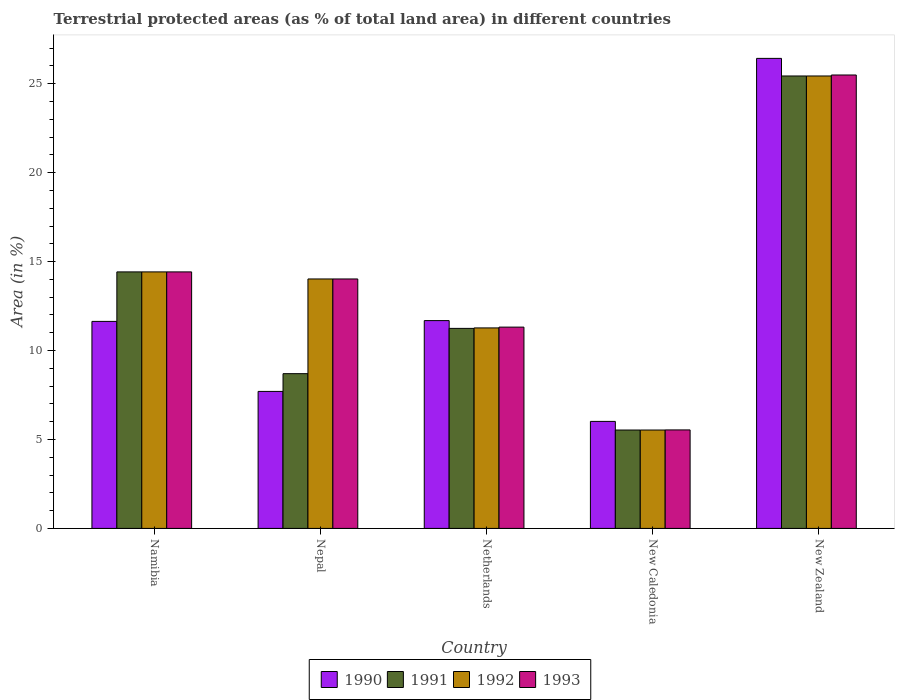Are the number of bars per tick equal to the number of legend labels?
Offer a very short reply. Yes. Are the number of bars on each tick of the X-axis equal?
Ensure brevity in your answer.  Yes. How many bars are there on the 4th tick from the left?
Provide a succinct answer. 4. What is the label of the 4th group of bars from the left?
Give a very brief answer. New Caledonia. In how many cases, is the number of bars for a given country not equal to the number of legend labels?
Keep it short and to the point. 0. What is the percentage of terrestrial protected land in 1991 in Nepal?
Make the answer very short. 8.7. Across all countries, what is the maximum percentage of terrestrial protected land in 1993?
Ensure brevity in your answer.  25.49. Across all countries, what is the minimum percentage of terrestrial protected land in 1990?
Provide a short and direct response. 6.02. In which country was the percentage of terrestrial protected land in 1990 maximum?
Ensure brevity in your answer.  New Zealand. In which country was the percentage of terrestrial protected land in 1992 minimum?
Your answer should be compact. New Caledonia. What is the total percentage of terrestrial protected land in 1990 in the graph?
Offer a terse response. 63.46. What is the difference between the percentage of terrestrial protected land in 1991 in Netherlands and that in New Caledonia?
Ensure brevity in your answer.  5.71. What is the difference between the percentage of terrestrial protected land in 1993 in Nepal and the percentage of terrestrial protected land in 1990 in Netherlands?
Offer a very short reply. 2.34. What is the average percentage of terrestrial protected land in 1991 per country?
Offer a terse response. 13.07. What is the difference between the percentage of terrestrial protected land of/in 1993 and percentage of terrestrial protected land of/in 1991 in Namibia?
Make the answer very short. 0. In how many countries, is the percentage of terrestrial protected land in 1992 greater than 2 %?
Your answer should be very brief. 5. What is the ratio of the percentage of terrestrial protected land in 1991 in Nepal to that in New Caledonia?
Your answer should be very brief. 1.57. Is the percentage of terrestrial protected land in 1993 in Namibia less than that in Netherlands?
Your answer should be compact. No. What is the difference between the highest and the second highest percentage of terrestrial protected land in 1993?
Your response must be concise. 11.07. What is the difference between the highest and the lowest percentage of terrestrial protected land in 1991?
Offer a terse response. 19.9. What does the 1st bar from the left in Nepal represents?
Provide a succinct answer. 1990. What does the 3rd bar from the right in Nepal represents?
Give a very brief answer. 1991. Is it the case that in every country, the sum of the percentage of terrestrial protected land in 1990 and percentage of terrestrial protected land in 1991 is greater than the percentage of terrestrial protected land in 1993?
Provide a short and direct response. Yes. How many countries are there in the graph?
Keep it short and to the point. 5. Does the graph contain any zero values?
Ensure brevity in your answer.  No. Does the graph contain grids?
Ensure brevity in your answer.  No. How are the legend labels stacked?
Keep it short and to the point. Horizontal. What is the title of the graph?
Offer a very short reply. Terrestrial protected areas (as % of total land area) in different countries. What is the label or title of the X-axis?
Your answer should be compact. Country. What is the label or title of the Y-axis?
Your answer should be very brief. Area (in %). What is the Area (in %) in 1990 in Namibia?
Ensure brevity in your answer.  11.64. What is the Area (in %) of 1991 in Namibia?
Your answer should be very brief. 14.42. What is the Area (in %) in 1992 in Namibia?
Make the answer very short. 14.42. What is the Area (in %) in 1993 in Namibia?
Ensure brevity in your answer.  14.42. What is the Area (in %) of 1990 in Nepal?
Provide a succinct answer. 7.7. What is the Area (in %) in 1991 in Nepal?
Your response must be concise. 8.7. What is the Area (in %) of 1992 in Nepal?
Offer a terse response. 14.02. What is the Area (in %) of 1993 in Nepal?
Provide a short and direct response. 14.02. What is the Area (in %) of 1990 in Netherlands?
Your response must be concise. 11.68. What is the Area (in %) in 1991 in Netherlands?
Provide a short and direct response. 11.25. What is the Area (in %) of 1992 in Netherlands?
Give a very brief answer. 11.27. What is the Area (in %) of 1993 in Netherlands?
Provide a short and direct response. 11.32. What is the Area (in %) in 1990 in New Caledonia?
Make the answer very short. 6.02. What is the Area (in %) in 1991 in New Caledonia?
Give a very brief answer. 5.53. What is the Area (in %) in 1992 in New Caledonia?
Ensure brevity in your answer.  5.53. What is the Area (in %) of 1993 in New Caledonia?
Make the answer very short. 5.54. What is the Area (in %) in 1990 in New Zealand?
Give a very brief answer. 26.42. What is the Area (in %) of 1991 in New Zealand?
Keep it short and to the point. 25.44. What is the Area (in %) in 1992 in New Zealand?
Your response must be concise. 25.44. What is the Area (in %) of 1993 in New Zealand?
Provide a succinct answer. 25.49. Across all countries, what is the maximum Area (in %) in 1990?
Give a very brief answer. 26.42. Across all countries, what is the maximum Area (in %) in 1991?
Give a very brief answer. 25.44. Across all countries, what is the maximum Area (in %) of 1992?
Offer a terse response. 25.44. Across all countries, what is the maximum Area (in %) in 1993?
Provide a succinct answer. 25.49. Across all countries, what is the minimum Area (in %) of 1990?
Your response must be concise. 6.02. Across all countries, what is the minimum Area (in %) of 1991?
Make the answer very short. 5.53. Across all countries, what is the minimum Area (in %) of 1992?
Your answer should be compact. 5.53. Across all countries, what is the minimum Area (in %) in 1993?
Give a very brief answer. 5.54. What is the total Area (in %) in 1990 in the graph?
Offer a very short reply. 63.46. What is the total Area (in %) in 1991 in the graph?
Provide a short and direct response. 65.33. What is the total Area (in %) in 1992 in the graph?
Your response must be concise. 70.68. What is the total Area (in %) of 1993 in the graph?
Your answer should be compact. 70.79. What is the difference between the Area (in %) in 1990 in Namibia and that in Nepal?
Give a very brief answer. 3.94. What is the difference between the Area (in %) in 1991 in Namibia and that in Nepal?
Make the answer very short. 5.72. What is the difference between the Area (in %) of 1992 in Namibia and that in Nepal?
Your response must be concise. 0.4. What is the difference between the Area (in %) in 1993 in Namibia and that in Nepal?
Give a very brief answer. 0.4. What is the difference between the Area (in %) in 1990 in Namibia and that in Netherlands?
Give a very brief answer. -0.04. What is the difference between the Area (in %) in 1991 in Namibia and that in Netherlands?
Your answer should be very brief. 3.18. What is the difference between the Area (in %) in 1992 in Namibia and that in Netherlands?
Keep it short and to the point. 3.15. What is the difference between the Area (in %) in 1993 in Namibia and that in Netherlands?
Keep it short and to the point. 3.1. What is the difference between the Area (in %) in 1990 in Namibia and that in New Caledonia?
Keep it short and to the point. 5.62. What is the difference between the Area (in %) in 1991 in Namibia and that in New Caledonia?
Your answer should be very brief. 8.89. What is the difference between the Area (in %) in 1992 in Namibia and that in New Caledonia?
Offer a terse response. 8.89. What is the difference between the Area (in %) of 1993 in Namibia and that in New Caledonia?
Ensure brevity in your answer.  8.88. What is the difference between the Area (in %) in 1990 in Namibia and that in New Zealand?
Keep it short and to the point. -14.79. What is the difference between the Area (in %) of 1991 in Namibia and that in New Zealand?
Ensure brevity in your answer.  -11.01. What is the difference between the Area (in %) in 1992 in Namibia and that in New Zealand?
Give a very brief answer. -11.02. What is the difference between the Area (in %) in 1993 in Namibia and that in New Zealand?
Give a very brief answer. -11.07. What is the difference between the Area (in %) in 1990 in Nepal and that in Netherlands?
Provide a short and direct response. -3.98. What is the difference between the Area (in %) in 1991 in Nepal and that in Netherlands?
Provide a succinct answer. -2.55. What is the difference between the Area (in %) in 1992 in Nepal and that in Netherlands?
Offer a terse response. 2.75. What is the difference between the Area (in %) of 1993 in Nepal and that in Netherlands?
Provide a short and direct response. 2.71. What is the difference between the Area (in %) of 1990 in Nepal and that in New Caledonia?
Your answer should be very brief. 1.69. What is the difference between the Area (in %) in 1991 in Nepal and that in New Caledonia?
Provide a short and direct response. 3.17. What is the difference between the Area (in %) of 1992 in Nepal and that in New Caledonia?
Your answer should be very brief. 8.49. What is the difference between the Area (in %) in 1993 in Nepal and that in New Caledonia?
Keep it short and to the point. 8.49. What is the difference between the Area (in %) in 1990 in Nepal and that in New Zealand?
Your answer should be compact. -18.72. What is the difference between the Area (in %) in 1991 in Nepal and that in New Zealand?
Provide a succinct answer. -16.74. What is the difference between the Area (in %) of 1992 in Nepal and that in New Zealand?
Provide a succinct answer. -11.41. What is the difference between the Area (in %) of 1993 in Nepal and that in New Zealand?
Ensure brevity in your answer.  -11.47. What is the difference between the Area (in %) of 1990 in Netherlands and that in New Caledonia?
Make the answer very short. 5.67. What is the difference between the Area (in %) of 1991 in Netherlands and that in New Caledonia?
Offer a terse response. 5.71. What is the difference between the Area (in %) in 1992 in Netherlands and that in New Caledonia?
Ensure brevity in your answer.  5.74. What is the difference between the Area (in %) in 1993 in Netherlands and that in New Caledonia?
Your answer should be compact. 5.78. What is the difference between the Area (in %) of 1990 in Netherlands and that in New Zealand?
Ensure brevity in your answer.  -14.74. What is the difference between the Area (in %) of 1991 in Netherlands and that in New Zealand?
Your response must be concise. -14.19. What is the difference between the Area (in %) of 1992 in Netherlands and that in New Zealand?
Your response must be concise. -14.16. What is the difference between the Area (in %) of 1993 in Netherlands and that in New Zealand?
Offer a very short reply. -14.17. What is the difference between the Area (in %) in 1990 in New Caledonia and that in New Zealand?
Make the answer very short. -20.41. What is the difference between the Area (in %) in 1991 in New Caledonia and that in New Zealand?
Keep it short and to the point. -19.9. What is the difference between the Area (in %) in 1992 in New Caledonia and that in New Zealand?
Your answer should be very brief. -19.9. What is the difference between the Area (in %) of 1993 in New Caledonia and that in New Zealand?
Your answer should be compact. -19.95. What is the difference between the Area (in %) in 1990 in Namibia and the Area (in %) in 1991 in Nepal?
Give a very brief answer. 2.94. What is the difference between the Area (in %) of 1990 in Namibia and the Area (in %) of 1992 in Nepal?
Provide a succinct answer. -2.39. What is the difference between the Area (in %) of 1990 in Namibia and the Area (in %) of 1993 in Nepal?
Give a very brief answer. -2.39. What is the difference between the Area (in %) of 1991 in Namibia and the Area (in %) of 1992 in Nepal?
Provide a short and direct response. 0.4. What is the difference between the Area (in %) in 1991 in Namibia and the Area (in %) in 1993 in Nepal?
Make the answer very short. 0.4. What is the difference between the Area (in %) in 1992 in Namibia and the Area (in %) in 1993 in Nepal?
Make the answer very short. 0.4. What is the difference between the Area (in %) in 1990 in Namibia and the Area (in %) in 1991 in Netherlands?
Your answer should be compact. 0.39. What is the difference between the Area (in %) in 1990 in Namibia and the Area (in %) in 1992 in Netherlands?
Keep it short and to the point. 0.37. What is the difference between the Area (in %) of 1990 in Namibia and the Area (in %) of 1993 in Netherlands?
Provide a succinct answer. 0.32. What is the difference between the Area (in %) in 1991 in Namibia and the Area (in %) in 1992 in Netherlands?
Your response must be concise. 3.15. What is the difference between the Area (in %) in 1991 in Namibia and the Area (in %) in 1993 in Netherlands?
Provide a short and direct response. 3.1. What is the difference between the Area (in %) in 1992 in Namibia and the Area (in %) in 1993 in Netherlands?
Give a very brief answer. 3.1. What is the difference between the Area (in %) in 1990 in Namibia and the Area (in %) in 1991 in New Caledonia?
Keep it short and to the point. 6.11. What is the difference between the Area (in %) of 1990 in Namibia and the Area (in %) of 1992 in New Caledonia?
Offer a terse response. 6.11. What is the difference between the Area (in %) in 1990 in Namibia and the Area (in %) in 1993 in New Caledonia?
Provide a short and direct response. 6.1. What is the difference between the Area (in %) of 1991 in Namibia and the Area (in %) of 1992 in New Caledonia?
Provide a short and direct response. 8.89. What is the difference between the Area (in %) in 1991 in Namibia and the Area (in %) in 1993 in New Caledonia?
Give a very brief answer. 8.88. What is the difference between the Area (in %) in 1992 in Namibia and the Area (in %) in 1993 in New Caledonia?
Offer a terse response. 8.88. What is the difference between the Area (in %) of 1990 in Namibia and the Area (in %) of 1991 in New Zealand?
Offer a very short reply. -13.8. What is the difference between the Area (in %) in 1990 in Namibia and the Area (in %) in 1992 in New Zealand?
Keep it short and to the point. -13.8. What is the difference between the Area (in %) of 1990 in Namibia and the Area (in %) of 1993 in New Zealand?
Keep it short and to the point. -13.85. What is the difference between the Area (in %) in 1991 in Namibia and the Area (in %) in 1992 in New Zealand?
Provide a short and direct response. -11.02. What is the difference between the Area (in %) of 1991 in Namibia and the Area (in %) of 1993 in New Zealand?
Give a very brief answer. -11.07. What is the difference between the Area (in %) of 1992 in Namibia and the Area (in %) of 1993 in New Zealand?
Offer a terse response. -11.07. What is the difference between the Area (in %) of 1990 in Nepal and the Area (in %) of 1991 in Netherlands?
Offer a terse response. -3.54. What is the difference between the Area (in %) in 1990 in Nepal and the Area (in %) in 1992 in Netherlands?
Your answer should be very brief. -3.57. What is the difference between the Area (in %) of 1990 in Nepal and the Area (in %) of 1993 in Netherlands?
Provide a short and direct response. -3.61. What is the difference between the Area (in %) of 1991 in Nepal and the Area (in %) of 1992 in Netherlands?
Offer a terse response. -2.57. What is the difference between the Area (in %) of 1991 in Nepal and the Area (in %) of 1993 in Netherlands?
Keep it short and to the point. -2.62. What is the difference between the Area (in %) of 1992 in Nepal and the Area (in %) of 1993 in Netherlands?
Keep it short and to the point. 2.71. What is the difference between the Area (in %) of 1990 in Nepal and the Area (in %) of 1991 in New Caledonia?
Provide a short and direct response. 2.17. What is the difference between the Area (in %) of 1990 in Nepal and the Area (in %) of 1992 in New Caledonia?
Provide a succinct answer. 2.17. What is the difference between the Area (in %) of 1990 in Nepal and the Area (in %) of 1993 in New Caledonia?
Give a very brief answer. 2.16. What is the difference between the Area (in %) in 1991 in Nepal and the Area (in %) in 1992 in New Caledonia?
Give a very brief answer. 3.17. What is the difference between the Area (in %) in 1991 in Nepal and the Area (in %) in 1993 in New Caledonia?
Ensure brevity in your answer.  3.16. What is the difference between the Area (in %) in 1992 in Nepal and the Area (in %) in 1993 in New Caledonia?
Make the answer very short. 8.49. What is the difference between the Area (in %) in 1990 in Nepal and the Area (in %) in 1991 in New Zealand?
Your response must be concise. -17.73. What is the difference between the Area (in %) of 1990 in Nepal and the Area (in %) of 1992 in New Zealand?
Offer a very short reply. -17.73. What is the difference between the Area (in %) in 1990 in Nepal and the Area (in %) in 1993 in New Zealand?
Keep it short and to the point. -17.79. What is the difference between the Area (in %) of 1991 in Nepal and the Area (in %) of 1992 in New Zealand?
Your answer should be very brief. -16.74. What is the difference between the Area (in %) of 1991 in Nepal and the Area (in %) of 1993 in New Zealand?
Make the answer very short. -16.79. What is the difference between the Area (in %) of 1992 in Nepal and the Area (in %) of 1993 in New Zealand?
Your answer should be compact. -11.47. What is the difference between the Area (in %) of 1990 in Netherlands and the Area (in %) of 1991 in New Caledonia?
Keep it short and to the point. 6.15. What is the difference between the Area (in %) in 1990 in Netherlands and the Area (in %) in 1992 in New Caledonia?
Provide a succinct answer. 6.15. What is the difference between the Area (in %) in 1990 in Netherlands and the Area (in %) in 1993 in New Caledonia?
Your answer should be very brief. 6.15. What is the difference between the Area (in %) in 1991 in Netherlands and the Area (in %) in 1992 in New Caledonia?
Ensure brevity in your answer.  5.71. What is the difference between the Area (in %) in 1991 in Netherlands and the Area (in %) in 1993 in New Caledonia?
Make the answer very short. 5.71. What is the difference between the Area (in %) in 1992 in Netherlands and the Area (in %) in 1993 in New Caledonia?
Give a very brief answer. 5.73. What is the difference between the Area (in %) of 1990 in Netherlands and the Area (in %) of 1991 in New Zealand?
Your response must be concise. -13.75. What is the difference between the Area (in %) of 1990 in Netherlands and the Area (in %) of 1992 in New Zealand?
Your answer should be compact. -13.75. What is the difference between the Area (in %) in 1990 in Netherlands and the Area (in %) in 1993 in New Zealand?
Your response must be concise. -13.81. What is the difference between the Area (in %) of 1991 in Netherlands and the Area (in %) of 1992 in New Zealand?
Offer a terse response. -14.19. What is the difference between the Area (in %) of 1991 in Netherlands and the Area (in %) of 1993 in New Zealand?
Provide a short and direct response. -14.25. What is the difference between the Area (in %) of 1992 in Netherlands and the Area (in %) of 1993 in New Zealand?
Offer a very short reply. -14.22. What is the difference between the Area (in %) of 1990 in New Caledonia and the Area (in %) of 1991 in New Zealand?
Provide a short and direct response. -19.42. What is the difference between the Area (in %) of 1990 in New Caledonia and the Area (in %) of 1992 in New Zealand?
Make the answer very short. -19.42. What is the difference between the Area (in %) in 1990 in New Caledonia and the Area (in %) in 1993 in New Zealand?
Keep it short and to the point. -19.47. What is the difference between the Area (in %) in 1991 in New Caledonia and the Area (in %) in 1992 in New Zealand?
Provide a succinct answer. -19.9. What is the difference between the Area (in %) in 1991 in New Caledonia and the Area (in %) in 1993 in New Zealand?
Provide a succinct answer. -19.96. What is the difference between the Area (in %) in 1992 in New Caledonia and the Area (in %) in 1993 in New Zealand?
Make the answer very short. -19.96. What is the average Area (in %) in 1990 per country?
Give a very brief answer. 12.69. What is the average Area (in %) of 1991 per country?
Provide a short and direct response. 13.07. What is the average Area (in %) of 1992 per country?
Your response must be concise. 14.14. What is the average Area (in %) of 1993 per country?
Your response must be concise. 14.16. What is the difference between the Area (in %) of 1990 and Area (in %) of 1991 in Namibia?
Keep it short and to the point. -2.78. What is the difference between the Area (in %) in 1990 and Area (in %) in 1992 in Namibia?
Make the answer very short. -2.78. What is the difference between the Area (in %) of 1990 and Area (in %) of 1993 in Namibia?
Your answer should be very brief. -2.78. What is the difference between the Area (in %) in 1991 and Area (in %) in 1992 in Namibia?
Ensure brevity in your answer.  0. What is the difference between the Area (in %) in 1991 and Area (in %) in 1993 in Namibia?
Ensure brevity in your answer.  0. What is the difference between the Area (in %) in 1992 and Area (in %) in 1993 in Namibia?
Ensure brevity in your answer.  0. What is the difference between the Area (in %) in 1990 and Area (in %) in 1991 in Nepal?
Provide a short and direct response. -1. What is the difference between the Area (in %) in 1990 and Area (in %) in 1992 in Nepal?
Your answer should be very brief. -6.32. What is the difference between the Area (in %) of 1990 and Area (in %) of 1993 in Nepal?
Provide a short and direct response. -6.32. What is the difference between the Area (in %) of 1991 and Area (in %) of 1992 in Nepal?
Your answer should be compact. -5.32. What is the difference between the Area (in %) in 1991 and Area (in %) in 1993 in Nepal?
Provide a short and direct response. -5.32. What is the difference between the Area (in %) of 1992 and Area (in %) of 1993 in Nepal?
Offer a very short reply. 0. What is the difference between the Area (in %) in 1990 and Area (in %) in 1991 in Netherlands?
Offer a terse response. 0.44. What is the difference between the Area (in %) of 1990 and Area (in %) of 1992 in Netherlands?
Your answer should be very brief. 0.41. What is the difference between the Area (in %) of 1990 and Area (in %) of 1993 in Netherlands?
Provide a short and direct response. 0.37. What is the difference between the Area (in %) in 1991 and Area (in %) in 1992 in Netherlands?
Offer a terse response. -0.03. What is the difference between the Area (in %) of 1991 and Area (in %) of 1993 in Netherlands?
Your response must be concise. -0.07. What is the difference between the Area (in %) of 1992 and Area (in %) of 1993 in Netherlands?
Offer a very short reply. -0.05. What is the difference between the Area (in %) in 1990 and Area (in %) in 1991 in New Caledonia?
Your answer should be very brief. 0.48. What is the difference between the Area (in %) of 1990 and Area (in %) of 1992 in New Caledonia?
Your answer should be compact. 0.48. What is the difference between the Area (in %) of 1990 and Area (in %) of 1993 in New Caledonia?
Give a very brief answer. 0.48. What is the difference between the Area (in %) of 1991 and Area (in %) of 1993 in New Caledonia?
Ensure brevity in your answer.  -0.01. What is the difference between the Area (in %) in 1992 and Area (in %) in 1993 in New Caledonia?
Provide a short and direct response. -0.01. What is the difference between the Area (in %) in 1990 and Area (in %) in 1991 in New Zealand?
Make the answer very short. 0.99. What is the difference between the Area (in %) in 1990 and Area (in %) in 1992 in New Zealand?
Offer a very short reply. 0.99. What is the difference between the Area (in %) of 1990 and Area (in %) of 1993 in New Zealand?
Your response must be concise. 0.93. What is the difference between the Area (in %) in 1991 and Area (in %) in 1992 in New Zealand?
Provide a short and direct response. -0. What is the difference between the Area (in %) in 1991 and Area (in %) in 1993 in New Zealand?
Ensure brevity in your answer.  -0.06. What is the difference between the Area (in %) in 1992 and Area (in %) in 1993 in New Zealand?
Your answer should be very brief. -0.06. What is the ratio of the Area (in %) of 1990 in Namibia to that in Nepal?
Ensure brevity in your answer.  1.51. What is the ratio of the Area (in %) of 1991 in Namibia to that in Nepal?
Give a very brief answer. 1.66. What is the ratio of the Area (in %) in 1992 in Namibia to that in Nepal?
Ensure brevity in your answer.  1.03. What is the ratio of the Area (in %) of 1993 in Namibia to that in Nepal?
Your answer should be compact. 1.03. What is the ratio of the Area (in %) in 1991 in Namibia to that in Netherlands?
Your response must be concise. 1.28. What is the ratio of the Area (in %) of 1992 in Namibia to that in Netherlands?
Offer a very short reply. 1.28. What is the ratio of the Area (in %) of 1993 in Namibia to that in Netherlands?
Keep it short and to the point. 1.27. What is the ratio of the Area (in %) of 1990 in Namibia to that in New Caledonia?
Give a very brief answer. 1.93. What is the ratio of the Area (in %) of 1991 in Namibia to that in New Caledonia?
Offer a terse response. 2.61. What is the ratio of the Area (in %) of 1992 in Namibia to that in New Caledonia?
Your answer should be compact. 2.61. What is the ratio of the Area (in %) of 1993 in Namibia to that in New Caledonia?
Keep it short and to the point. 2.6. What is the ratio of the Area (in %) in 1990 in Namibia to that in New Zealand?
Make the answer very short. 0.44. What is the ratio of the Area (in %) of 1991 in Namibia to that in New Zealand?
Ensure brevity in your answer.  0.57. What is the ratio of the Area (in %) in 1992 in Namibia to that in New Zealand?
Make the answer very short. 0.57. What is the ratio of the Area (in %) of 1993 in Namibia to that in New Zealand?
Offer a terse response. 0.57. What is the ratio of the Area (in %) of 1990 in Nepal to that in Netherlands?
Keep it short and to the point. 0.66. What is the ratio of the Area (in %) of 1991 in Nepal to that in Netherlands?
Keep it short and to the point. 0.77. What is the ratio of the Area (in %) in 1992 in Nepal to that in Netherlands?
Your answer should be compact. 1.24. What is the ratio of the Area (in %) of 1993 in Nepal to that in Netherlands?
Keep it short and to the point. 1.24. What is the ratio of the Area (in %) in 1990 in Nepal to that in New Caledonia?
Offer a very short reply. 1.28. What is the ratio of the Area (in %) of 1991 in Nepal to that in New Caledonia?
Provide a succinct answer. 1.57. What is the ratio of the Area (in %) in 1992 in Nepal to that in New Caledonia?
Your answer should be very brief. 2.54. What is the ratio of the Area (in %) in 1993 in Nepal to that in New Caledonia?
Offer a very short reply. 2.53. What is the ratio of the Area (in %) in 1990 in Nepal to that in New Zealand?
Your answer should be very brief. 0.29. What is the ratio of the Area (in %) in 1991 in Nepal to that in New Zealand?
Offer a very short reply. 0.34. What is the ratio of the Area (in %) in 1992 in Nepal to that in New Zealand?
Your answer should be compact. 0.55. What is the ratio of the Area (in %) in 1993 in Nepal to that in New Zealand?
Provide a succinct answer. 0.55. What is the ratio of the Area (in %) of 1990 in Netherlands to that in New Caledonia?
Give a very brief answer. 1.94. What is the ratio of the Area (in %) in 1991 in Netherlands to that in New Caledonia?
Provide a succinct answer. 2.03. What is the ratio of the Area (in %) in 1992 in Netherlands to that in New Caledonia?
Provide a short and direct response. 2.04. What is the ratio of the Area (in %) of 1993 in Netherlands to that in New Caledonia?
Offer a very short reply. 2.04. What is the ratio of the Area (in %) of 1990 in Netherlands to that in New Zealand?
Keep it short and to the point. 0.44. What is the ratio of the Area (in %) in 1991 in Netherlands to that in New Zealand?
Ensure brevity in your answer.  0.44. What is the ratio of the Area (in %) in 1992 in Netherlands to that in New Zealand?
Offer a terse response. 0.44. What is the ratio of the Area (in %) in 1993 in Netherlands to that in New Zealand?
Provide a succinct answer. 0.44. What is the ratio of the Area (in %) in 1990 in New Caledonia to that in New Zealand?
Offer a very short reply. 0.23. What is the ratio of the Area (in %) in 1991 in New Caledonia to that in New Zealand?
Make the answer very short. 0.22. What is the ratio of the Area (in %) in 1992 in New Caledonia to that in New Zealand?
Make the answer very short. 0.22. What is the ratio of the Area (in %) of 1993 in New Caledonia to that in New Zealand?
Make the answer very short. 0.22. What is the difference between the highest and the second highest Area (in %) of 1990?
Make the answer very short. 14.74. What is the difference between the highest and the second highest Area (in %) in 1991?
Provide a succinct answer. 11.01. What is the difference between the highest and the second highest Area (in %) in 1992?
Provide a short and direct response. 11.02. What is the difference between the highest and the second highest Area (in %) of 1993?
Keep it short and to the point. 11.07. What is the difference between the highest and the lowest Area (in %) of 1990?
Keep it short and to the point. 20.41. What is the difference between the highest and the lowest Area (in %) in 1991?
Ensure brevity in your answer.  19.9. What is the difference between the highest and the lowest Area (in %) in 1992?
Make the answer very short. 19.9. What is the difference between the highest and the lowest Area (in %) of 1993?
Offer a terse response. 19.95. 